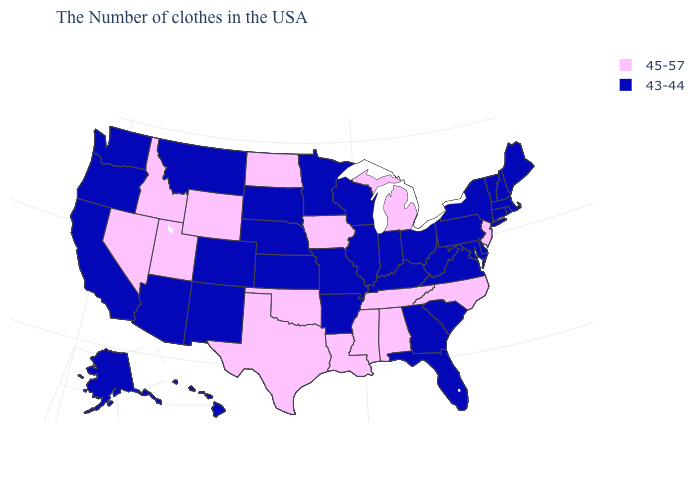What is the value of New Hampshire?
Short answer required. 43-44. Which states have the highest value in the USA?
Quick response, please. New Jersey, North Carolina, Michigan, Alabama, Tennessee, Mississippi, Louisiana, Iowa, Oklahoma, Texas, North Dakota, Wyoming, Utah, Idaho, Nevada. What is the value of South Dakota?
Answer briefly. 43-44. Does the map have missing data?
Be succinct. No. Name the states that have a value in the range 43-44?
Short answer required. Maine, Massachusetts, Rhode Island, New Hampshire, Vermont, Connecticut, New York, Delaware, Maryland, Pennsylvania, Virginia, South Carolina, West Virginia, Ohio, Florida, Georgia, Kentucky, Indiana, Wisconsin, Illinois, Missouri, Arkansas, Minnesota, Kansas, Nebraska, South Dakota, Colorado, New Mexico, Montana, Arizona, California, Washington, Oregon, Alaska, Hawaii. Name the states that have a value in the range 45-57?
Be succinct. New Jersey, North Carolina, Michigan, Alabama, Tennessee, Mississippi, Louisiana, Iowa, Oklahoma, Texas, North Dakota, Wyoming, Utah, Idaho, Nevada. Is the legend a continuous bar?
Keep it brief. No. Is the legend a continuous bar?
Quick response, please. No. What is the value of South Dakota?
Keep it brief. 43-44. Among the states that border Indiana , which have the highest value?
Write a very short answer. Michigan. What is the highest value in states that border Alabama?
Quick response, please. 45-57. Name the states that have a value in the range 45-57?
Concise answer only. New Jersey, North Carolina, Michigan, Alabama, Tennessee, Mississippi, Louisiana, Iowa, Oklahoma, Texas, North Dakota, Wyoming, Utah, Idaho, Nevada. Name the states that have a value in the range 45-57?
Quick response, please. New Jersey, North Carolina, Michigan, Alabama, Tennessee, Mississippi, Louisiana, Iowa, Oklahoma, Texas, North Dakota, Wyoming, Utah, Idaho, Nevada. What is the highest value in states that border Illinois?
Keep it brief. 45-57. Is the legend a continuous bar?
Answer briefly. No. 